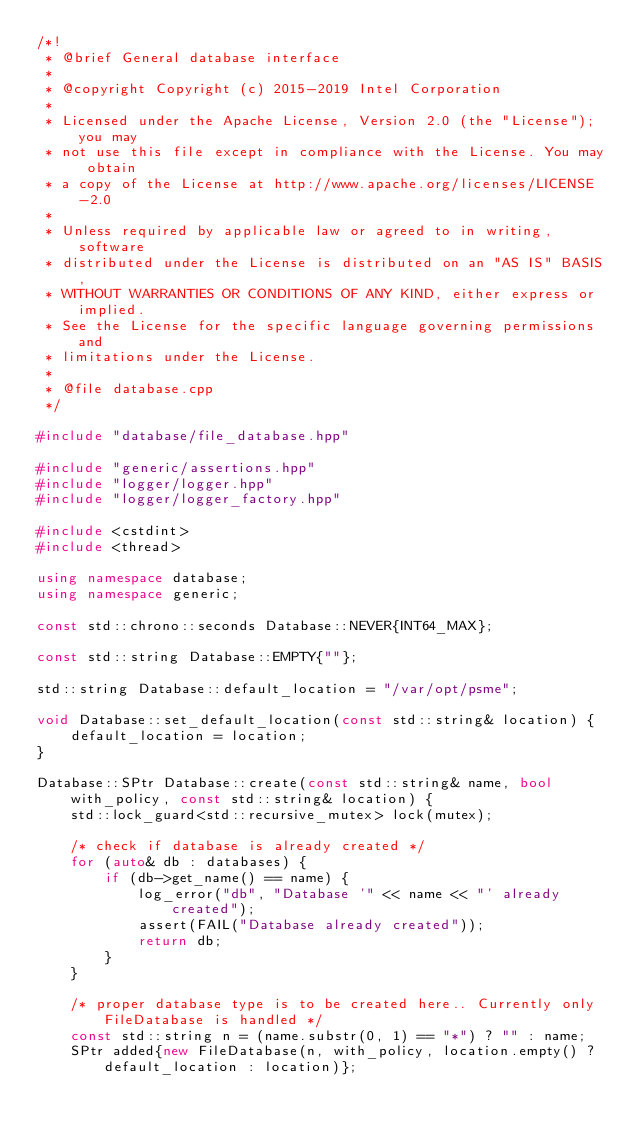Convert code to text. <code><loc_0><loc_0><loc_500><loc_500><_C++_>/*!
 * @brief General database interface
 *
 * @copyright Copyright (c) 2015-2019 Intel Corporation
 *
 * Licensed under the Apache License, Version 2.0 (the "License"); you may
 * not use this file except in compliance with the License. You may obtain
 * a copy of the License at http://www.apache.org/licenses/LICENSE-2.0
 *
 * Unless required by applicable law or agreed to in writing, software
 * distributed under the License is distributed on an "AS IS" BASIS,
 * WITHOUT WARRANTIES OR CONDITIONS OF ANY KIND, either express or implied.
 * See the License for the specific language governing permissions and
 * limitations under the License.
 *
 * @file database.cpp
 */

#include "database/file_database.hpp"

#include "generic/assertions.hpp"
#include "logger/logger.hpp"
#include "logger/logger_factory.hpp"

#include <cstdint>
#include <thread>

using namespace database;
using namespace generic;

const std::chrono::seconds Database::NEVER{INT64_MAX};

const std::string Database::EMPTY{""};

std::string Database::default_location = "/var/opt/psme";

void Database::set_default_location(const std::string& location) {
    default_location = location;
}

Database::SPtr Database::create(const std::string& name, bool with_policy, const std::string& location) {
    std::lock_guard<std::recursive_mutex> lock(mutex);

    /* check if database is already created */
    for (auto& db : databases) {
        if (db->get_name() == name) {
            log_error("db", "Database '" << name << "' already created");
            assert(FAIL("Database already created"));
            return db;
        }
    }

    /* proper database type is to be created here.. Currently only FileDatabase is handled */
    const std::string n = (name.substr(0, 1) == "*") ? "" : name;
    SPtr added{new FileDatabase(n, with_policy, location.empty() ? default_location : location)};
</code> 